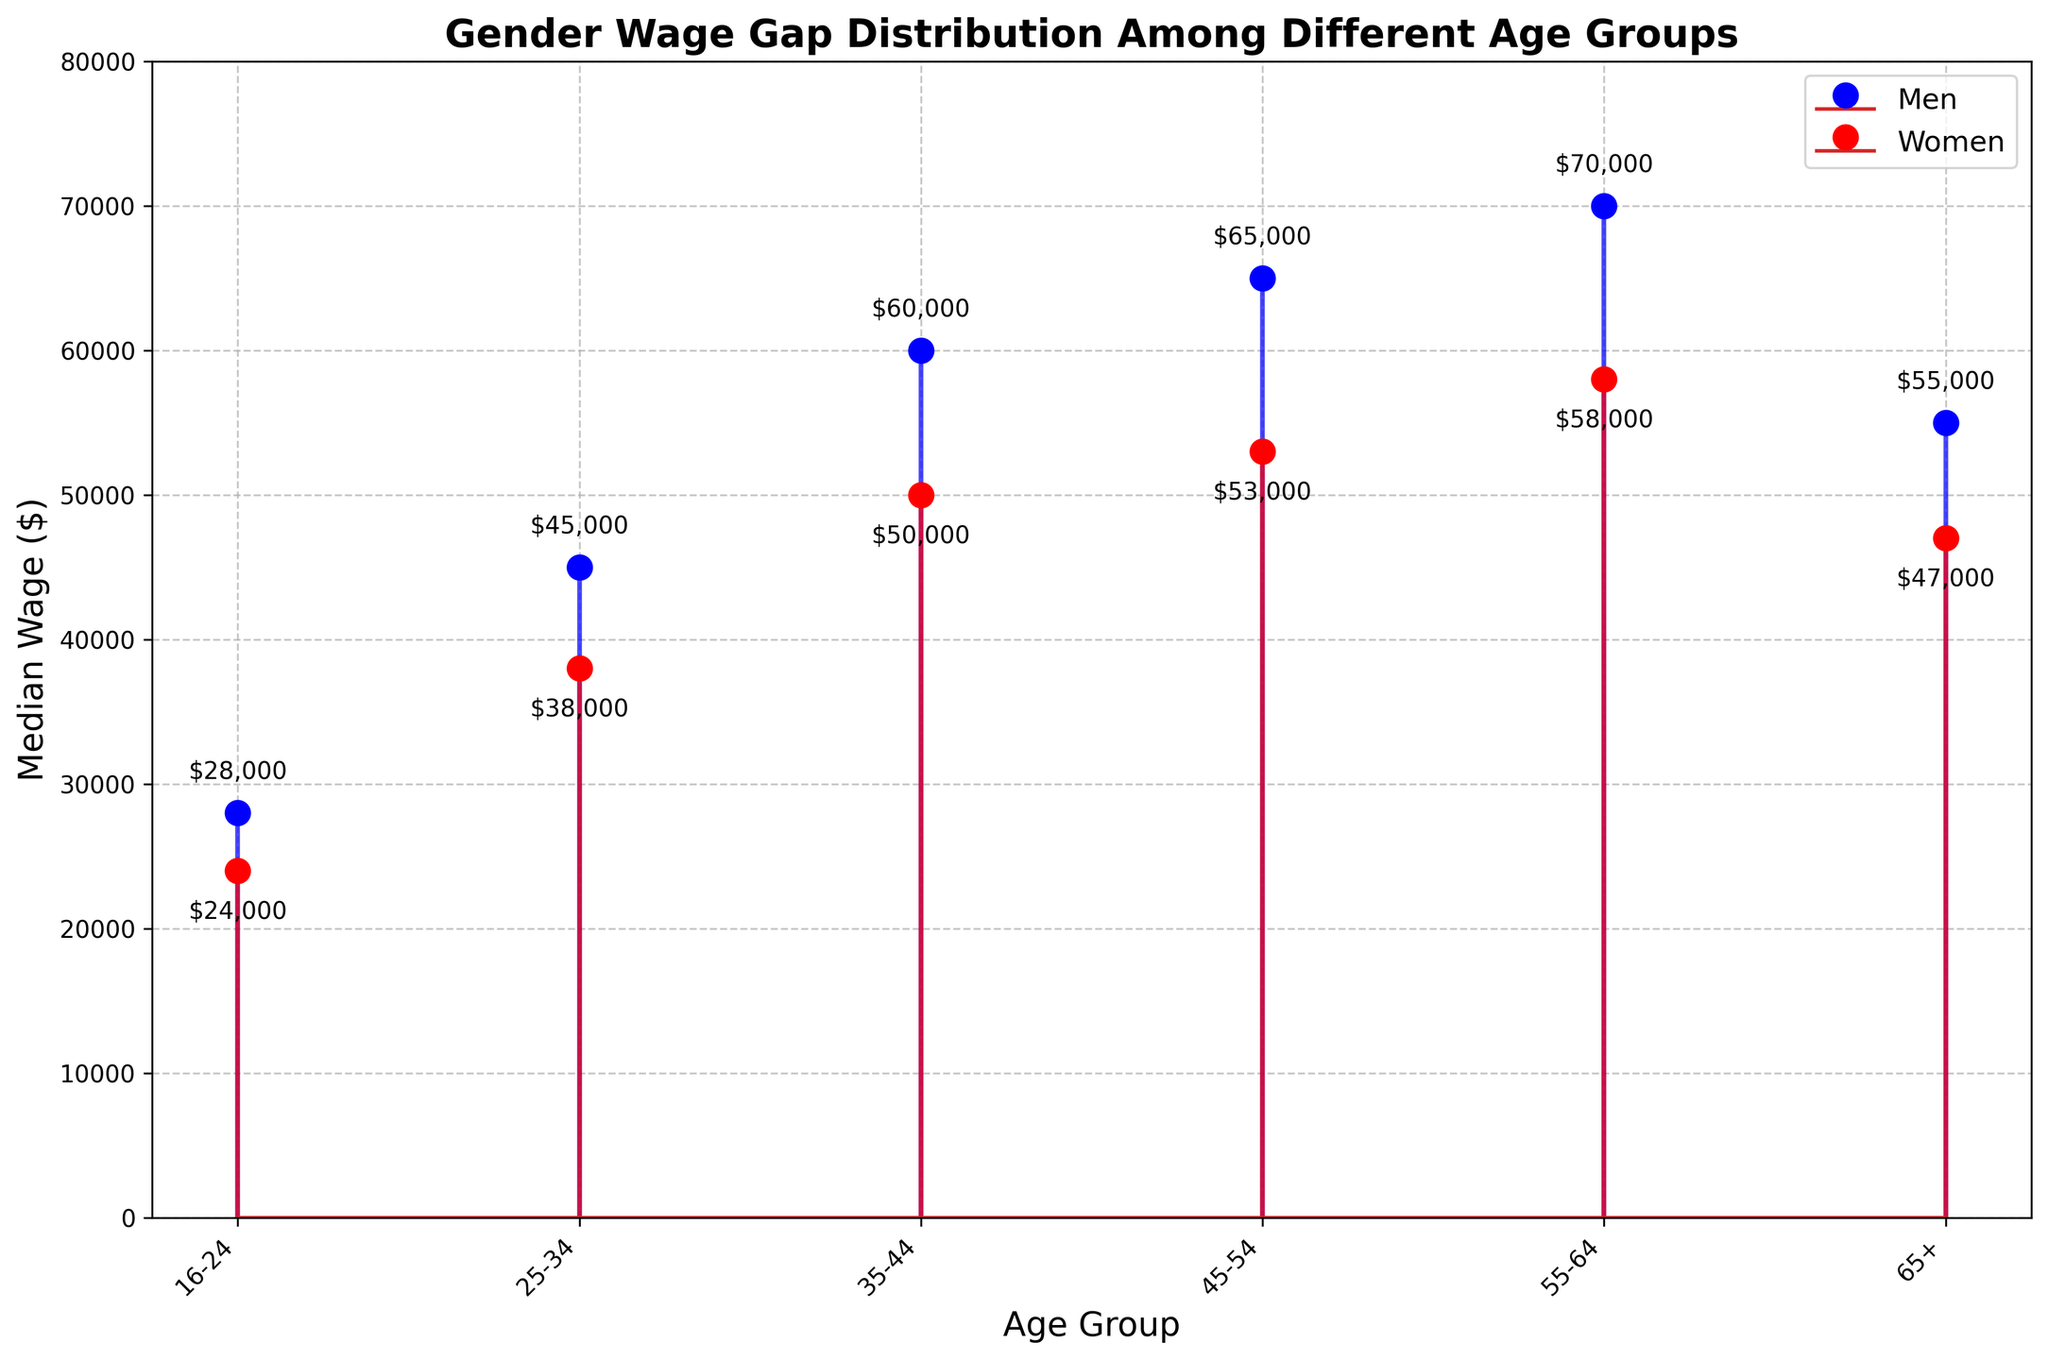What's the title of the figure? At the top of the figure, there is a large, bold text that provides the title. It says "Gender Wage Gap Distribution Among Different Age Groups".
Answer: Gender Wage Gap Distribution Among Different Age Groups How many age groups are presented in the figure? The x-axis shows labels for each age group. Counting these labels gives us six different age groups.
Answer: 6 What is the median wage for women in the 25-34 age group? Look at the red stem that corresponds to the 25-34 age group. The red marker shows the median wage for women. The label near the marker indicates $38,000.
Answer: $38,000 Which age group has the biggest wage gap between men and women? To find the largest gap, subtract the median wage for women from the median wage for men for each age group: (1) 16-24: 28000-24000 = 4000, (2) 25-34: 45000-38000 = 7000, (3) 35-44: 60000-50000 = 10000, (4) 45-54: 65000-53000 = 12000, (5) 55-64: 70000-58000 = 12000, (6) 65+: 55000-47000 = 8000. The biggest gaps are found in the 45-54 and 55-64 age groups, both with a gap of 12,000.
Answer: 45-54 and 55-64 What are the colors used to represent men's and women's median wages in the figure? The figure uses two distinct solid lines and markers: blue for men and red for women.
Answer: Blue and red What is the average median wage for men across all age groups? To find the average, sum the median wages for men across all age groups and divide by the number of groups. The values are 28000, 45000, 60000, 65000, 70000, and 55000. The sum is 323000, and dividing by 6 gives an average of 53833.33.
Answer: $53,833.33 Which age group shows the smallest increase in median wage for women compared to the previous age group? Compare the difference in median wage for women between consecutive age groups: 
(1) 16-24 to 25-34: 38000 - 24000 = 14000
(2) 25-34 to 35-44: 50000 - 38000 = 12000
(3) 35-44 to 45-54: 53000 - 50000 = 3000
(4) 45-54 to 55-64: 58000 - 53000 = 5000
(5) 55-64 to 65+: 47000 - 58000 = -11000 (decrease)
The smallest increase is from 35-44 to 45-54 with only a 3000 increase.
Answer: 45-54 